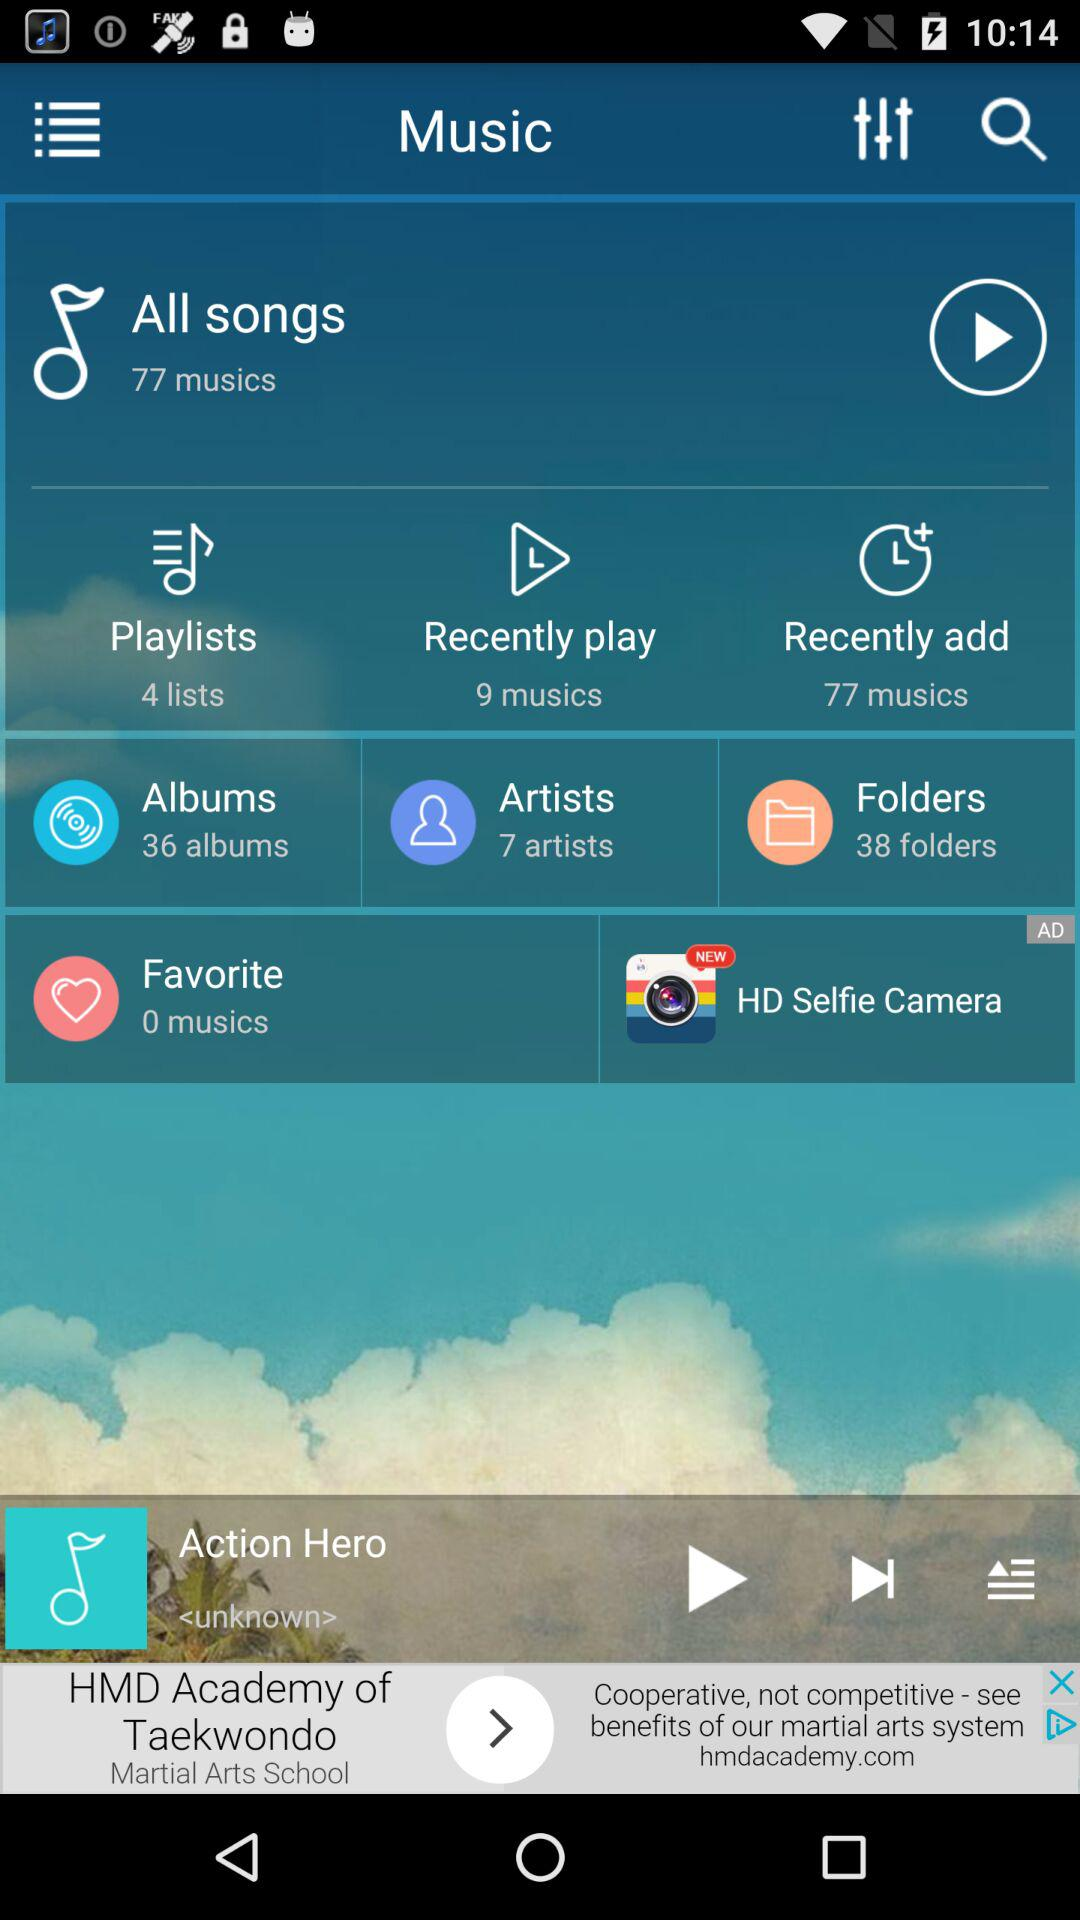How many recently added musics are there? There are 77 musics. 